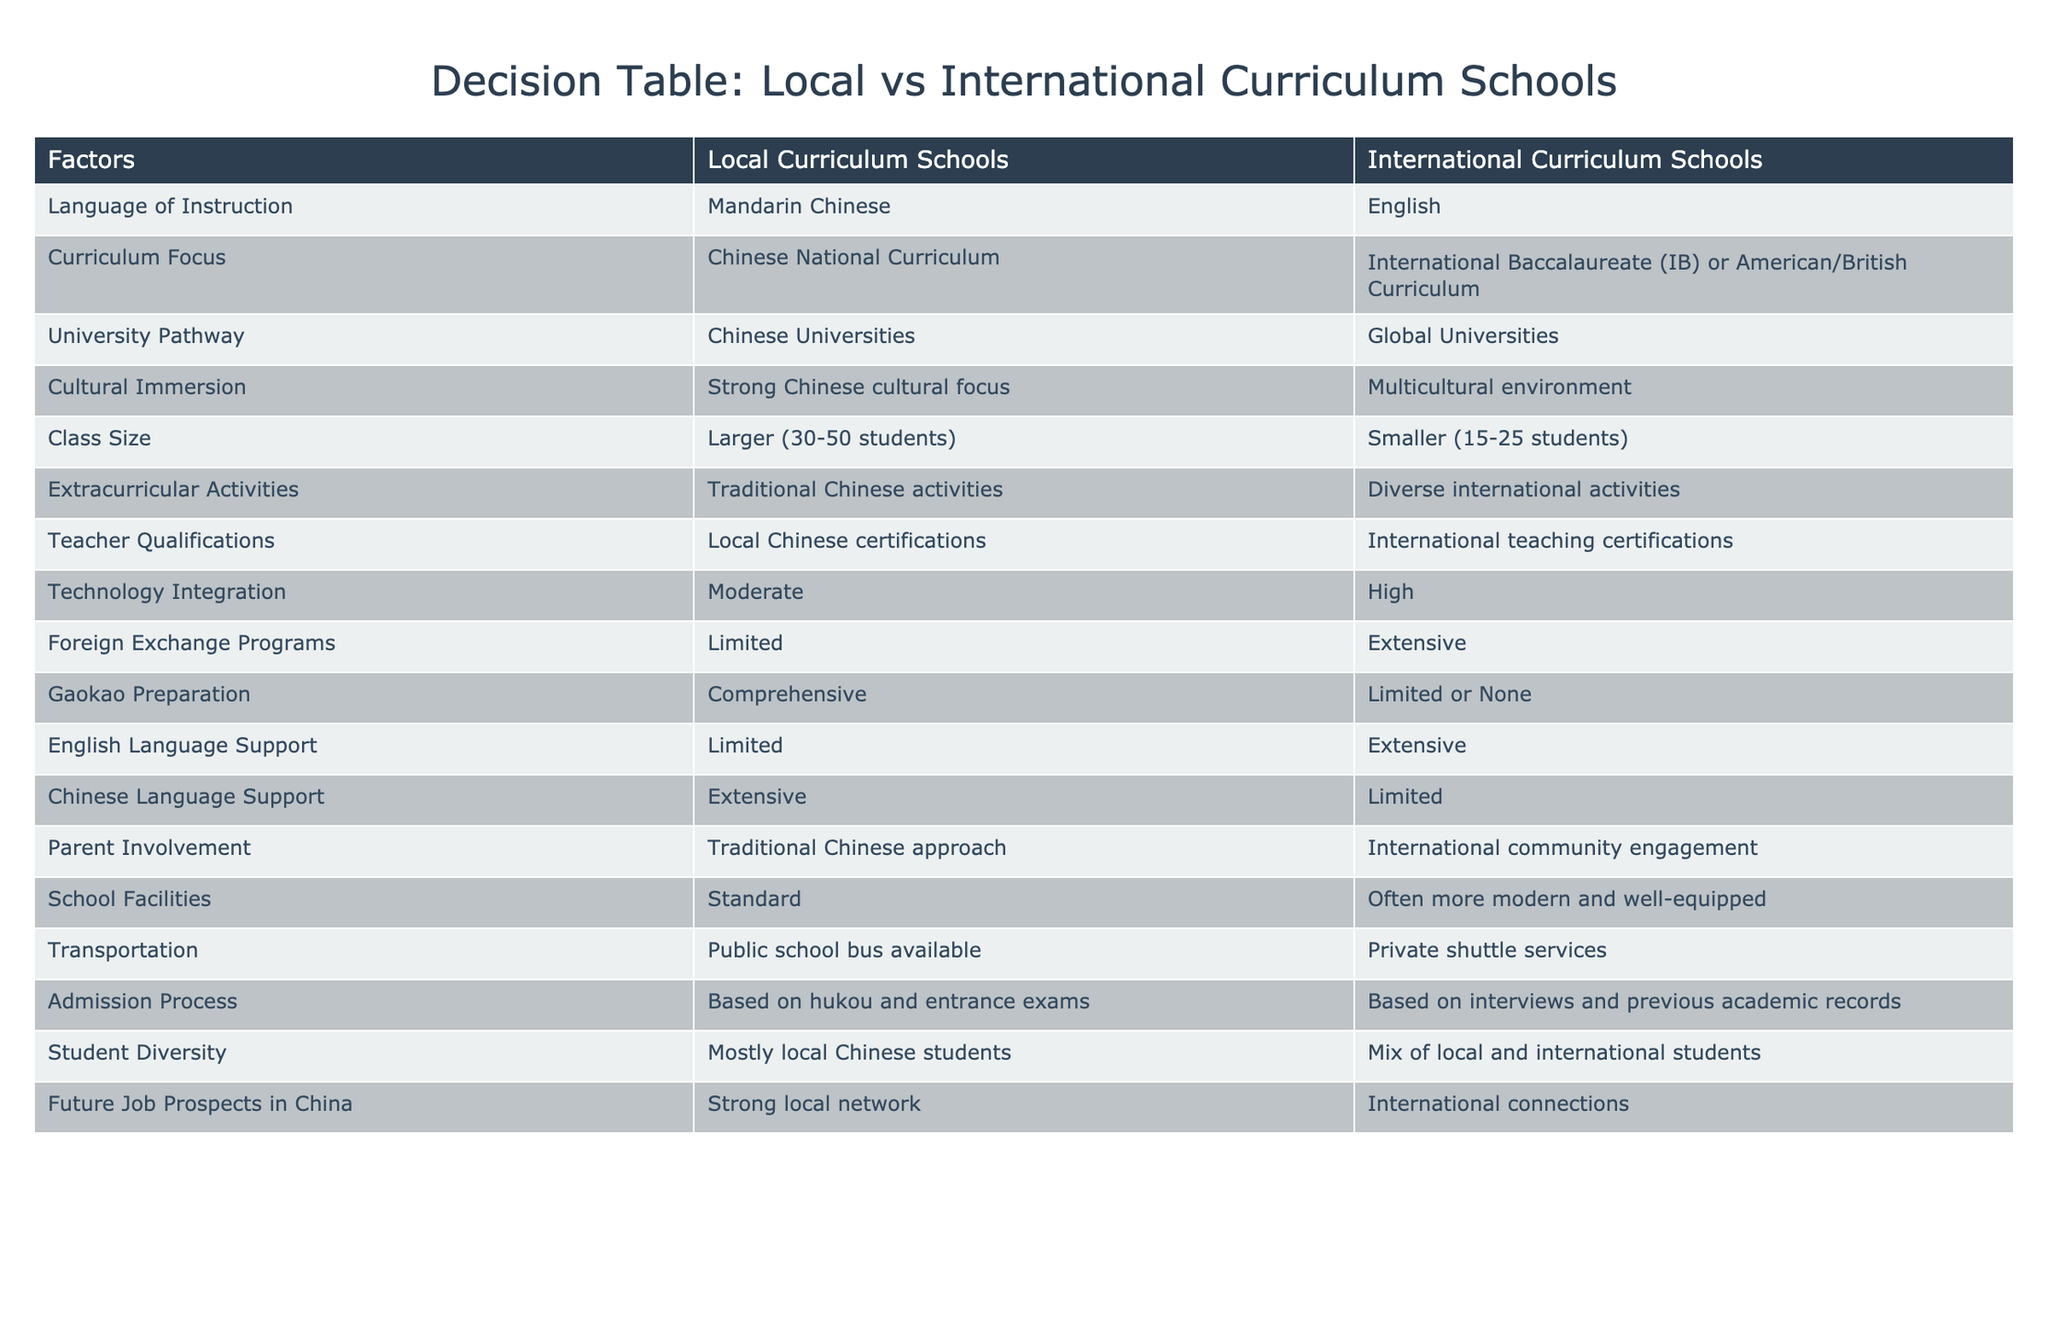What is the language of instruction in local curriculum schools? The table directly states that the language of instruction in local curriculum schools is Mandarin Chinese.
Answer: Mandarin Chinese How many students are there typically in a class at international curriculum schools? The table indicates that international curriculum schools have smaller class sizes, typically between 15 to 25 students.
Answer: 15-25 students Which type of school provides comprehensive Gaokao preparation? Referring to the table, it is clear that local curriculum schools offer comprehensive Gaokao preparation, while international schools provide limited or none.
Answer: Local curriculum schools Is teacher qualification different between the two types of schools? Yes, according to the table, local curriculum schools require local Chinese certifications for teachers, whereas international curriculum schools require international teaching certifications.
Answer: Yes What is the difference in technology integration between local and international curriculum schools? The table shows that local curriculum schools have moderate technology integration, while international curriculum schools have high technology integration.
Answer: Moderate vs High What are the future job prospects for students from local curriculum schools compared to international curriculum schools? The table mentions that local curriculum schools provide strong local networks for future job prospects, while international curriculum schools offer international connections, indicating a different focus.
Answer: Different focus If a parent values multicultural environments, which type of school should they consider? The table highlights that international curriculum schools provide a multicultural environment, which would be more suitable for parents valuing such diversity.
Answer: International curriculum schools How many factors indicate that international curriculum schools have better English language support compared to local curriculum schools? By comparing the entries in the table, we see that international curriculum schools have extensive English language support, while local curriculum schools have limited. This clearly indicates a better offering in international schools.
Answer: 1 factor (better support) What advantages do international curriculum schools have in terms of extracurricular activities? The table shows that international curriculum schools offer diverse international activities for extracurricular engagement, while local curriculum schools focus on traditional Chinese activities. This implies that international schools have a broader range of options.
Answer: Diverse international activities 